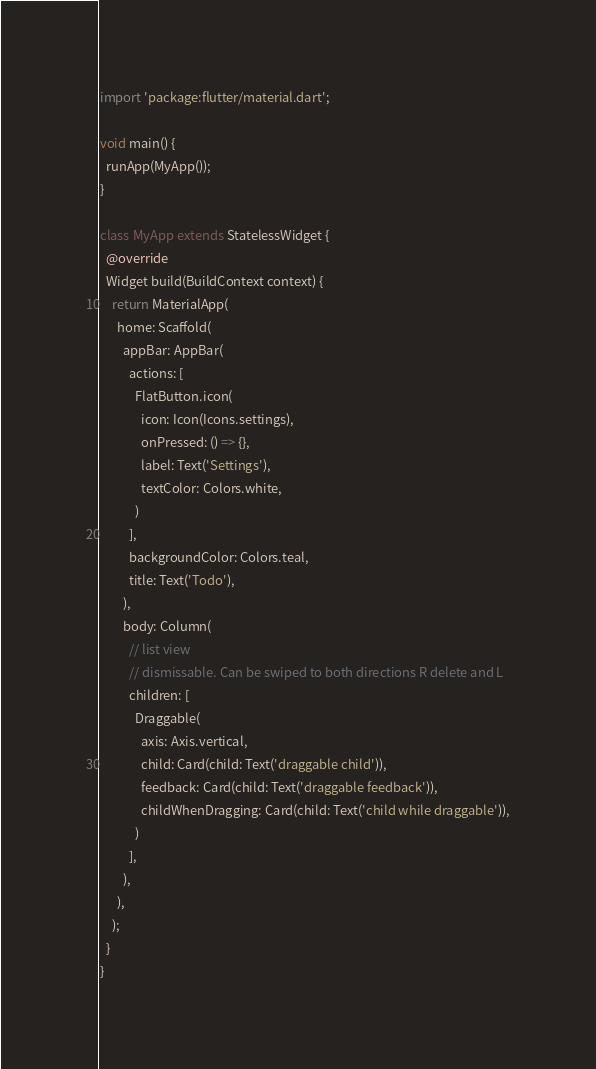Convert code to text. <code><loc_0><loc_0><loc_500><loc_500><_Dart_>import 'package:flutter/material.dart';

void main() {
  runApp(MyApp());
}

class MyApp extends StatelessWidget {
  @override
  Widget build(BuildContext context) {
    return MaterialApp(
      home: Scaffold(
        appBar: AppBar(
          actions: [
            FlatButton.icon(
              icon: Icon(Icons.settings),
              onPressed: () => {},
              label: Text('Settings'),
              textColor: Colors.white,
            )
          ],
          backgroundColor: Colors.teal,
          title: Text('Todo'),
        ),
        body: Column(
          // list view
          // dismissable. Can be swiped to both directions R delete and L
          children: [
            Draggable(
              axis: Axis.vertical,
              child: Card(child: Text('draggable child')),
              feedback: Card(child: Text('draggable feedback')),
              childWhenDragging: Card(child: Text('child while draggable')),
            )
          ],
        ),
      ),
    );
  }
}
</code> 